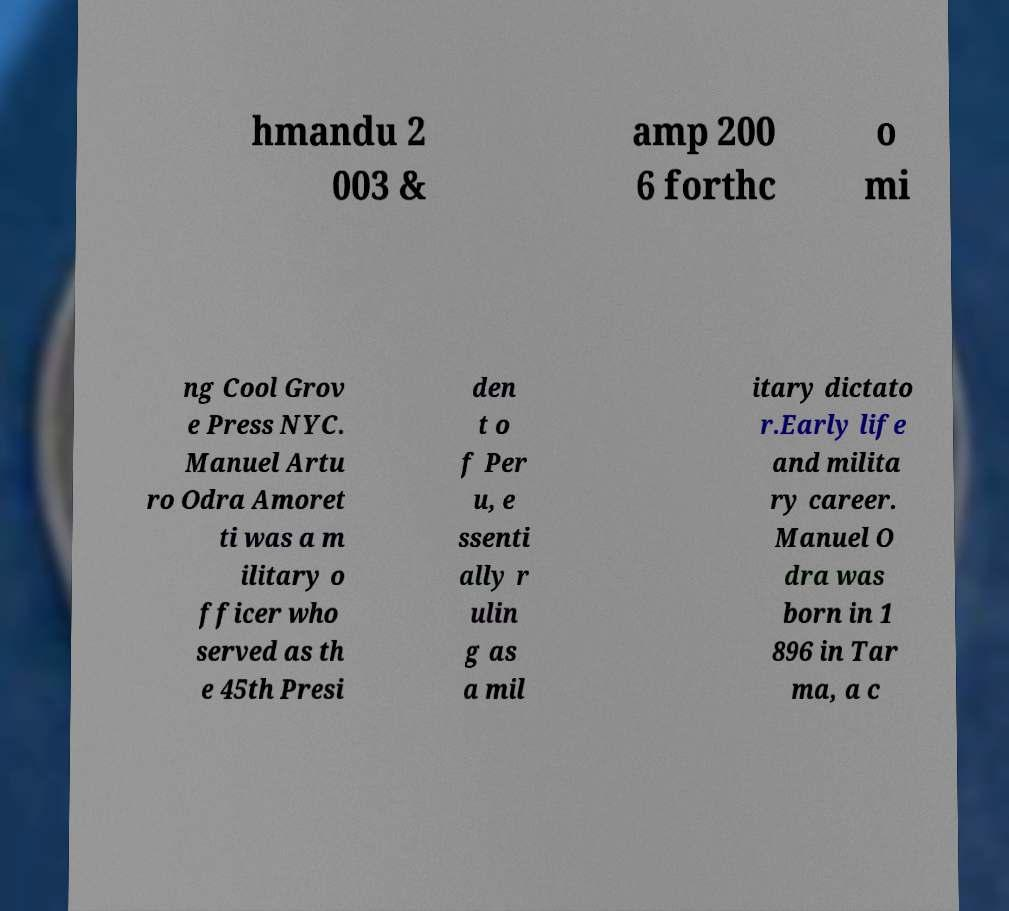Can you read and provide the text displayed in the image?This photo seems to have some interesting text. Can you extract and type it out for me? hmandu 2 003 & amp 200 6 forthc o mi ng Cool Grov e Press NYC. Manuel Artu ro Odra Amoret ti was a m ilitary o fficer who served as th e 45th Presi den t o f Per u, e ssenti ally r ulin g as a mil itary dictato r.Early life and milita ry career. Manuel O dra was born in 1 896 in Tar ma, a c 